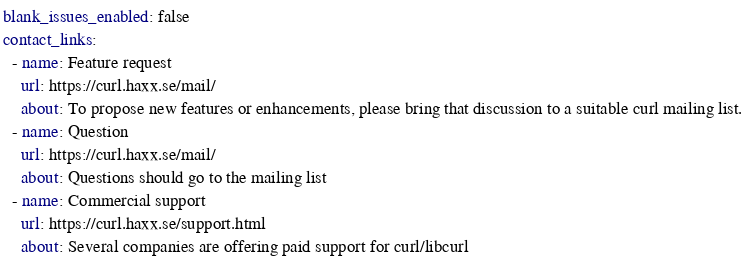<code> <loc_0><loc_0><loc_500><loc_500><_YAML_>blank_issues_enabled: false
contact_links:
  - name: Feature request
    url: https://curl.haxx.se/mail/
    about: To propose new features or enhancements, please bring that discussion to a suitable curl mailing list.
  - name: Question
    url: https://curl.haxx.se/mail/
    about: Questions should go to the mailing list
  - name: Commercial support
    url: https://curl.haxx.se/support.html
    about: Several companies are offering paid support for curl/libcurl
</code> 